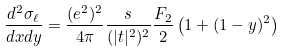Convert formula to latex. <formula><loc_0><loc_0><loc_500><loc_500>\frac { d ^ { 2 } \sigma _ { \ell } } { d x d y } = \frac { ( e ^ { 2 } ) ^ { 2 } } { 4 \pi } \frac { s } { ( | t | ^ { 2 } ) ^ { 2 } } \frac { F _ { 2 } } { 2 } \left ( 1 + ( 1 - y ) ^ { 2 } \right )</formula> 